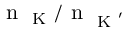Convert formula to latex. <formula><loc_0><loc_0><loc_500><loc_500>n _ { K } / n _ { K ^ { \prime } }</formula> 